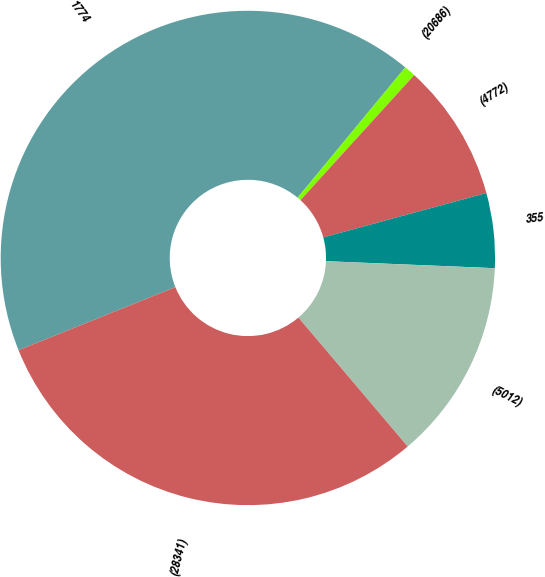Convert chart to OTSL. <chart><loc_0><loc_0><loc_500><loc_500><pie_chart><fcel>1774<fcel>(20686)<fcel>(4772)<fcel>355<fcel>(5012)<fcel>(28341)<nl><fcel>42.07%<fcel>0.76%<fcel>9.02%<fcel>4.89%<fcel>13.15%<fcel>30.1%<nl></chart> 